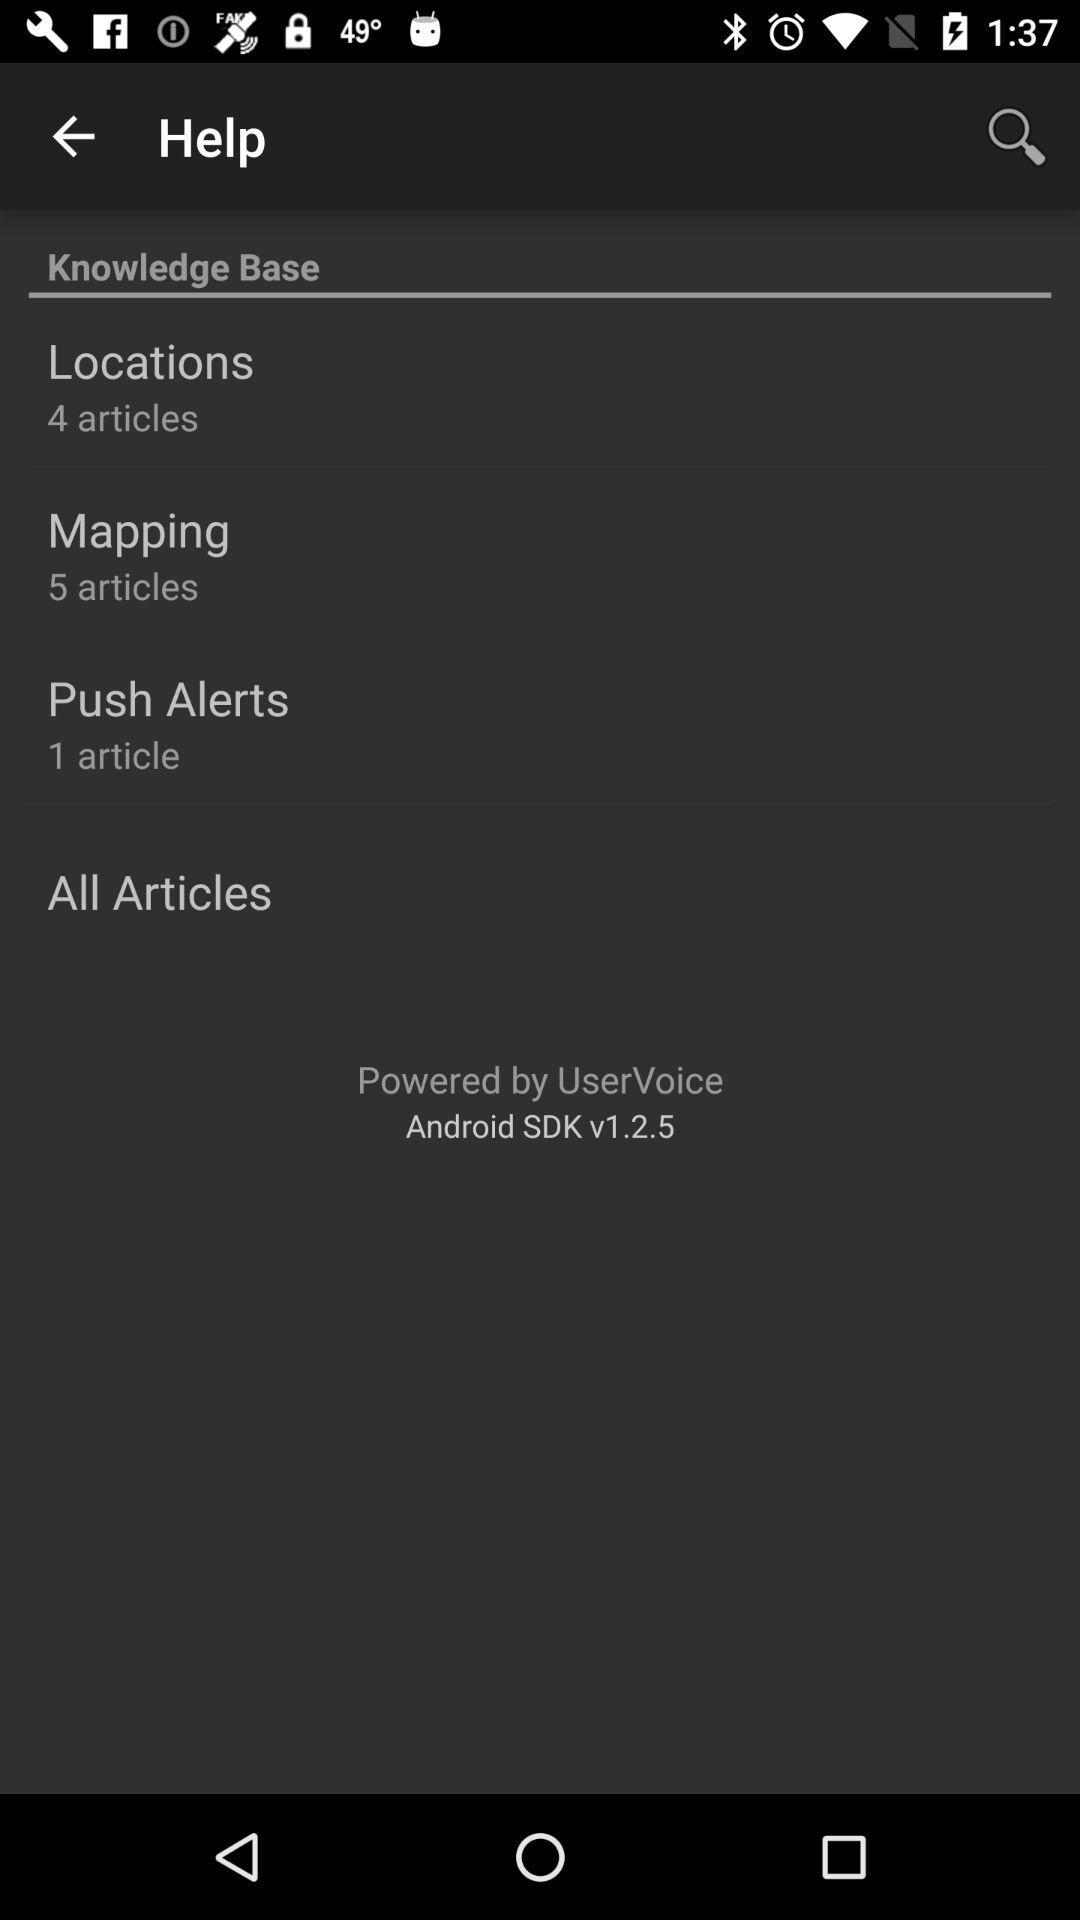How many articles are in the Push Alerts section?
Answer the question using a single word or phrase. 1 